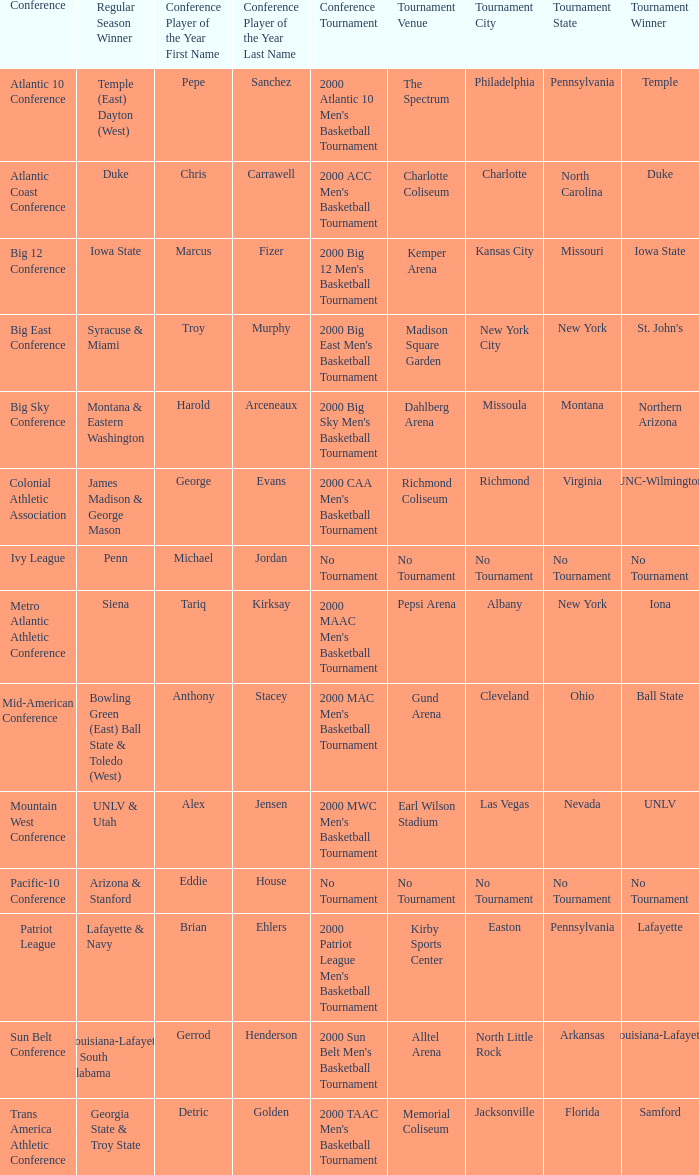Who is the conference Player of the Year in the conference where Lafayette won the tournament? Brian Ehlers , Lafayette. 